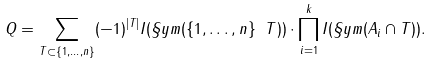Convert formula to latex. <formula><loc_0><loc_0><loc_500><loc_500>Q = \sum _ { T \subset \{ 1 , \dots , n \} } ( - 1 ) ^ { | T | } I ( \S y m ( \{ 1 , \dots , n \} \ T ) ) \cdot \prod _ { i = 1 } ^ { k } I ( \S y m ( A _ { i } \cap T ) ) .</formula> 